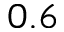<formula> <loc_0><loc_0><loc_500><loc_500>0 . 6</formula> 